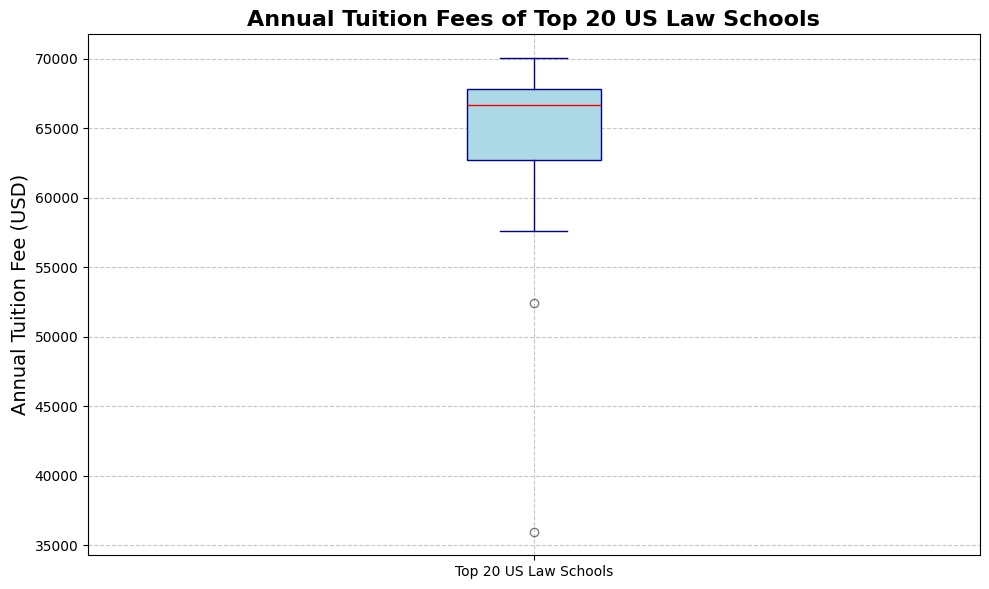What is the median annual tuition fee for the top 20 US law schools? The red line inside the box plot represents the median. By looking at this line, we can identify the median tuition fee.
Answer: $67,582 What is the interquartile range (IQR) of the annual tuition fees? The IQR is the difference between the third quartile (Q3) and the first quartile (Q1). It represents the middle 50% of the data. By observing the range covered by the box in the box plot, we can determine the Q1 and Q3 values and find their difference.
Answer: $6,154 How does the highest tuition fee compare to the lowest tuition fee among the top 20 law schools? The whiskers on the box plot indicate the minimum and maximum tuition fees. By comparing the heights of the whiskers, we can deduce the range of tuition fees.
Answer: The highest is significantly higher than the lowest Which law school has the outlier tuition fee, and how can you identify it? Outliers are indicated by points outside the whiskers. In the box plot, an orange point represents the outlier and thus can be easily identified.
Answer: University of Texas--Austin School of Law How many law schools have tuition fees above the median? The median marks the 50th percentile. By counting the number of points above the red median line within the distribution, we can determine how many schools have above-median fees.
Answer: 10 Is the distribution of the annual tuition fees symmetrical or skewed? We can determine this by looking at the symmetry of the box and whiskers around the median line. If one side of the box and whiskers is longer than the other, it indicates skewness.
Answer: Skewed to the left 